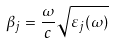Convert formula to latex. <formula><loc_0><loc_0><loc_500><loc_500>\beta _ { j } = \frac { \omega } { c } \sqrt { \varepsilon _ { j } ( \omega ) }</formula> 